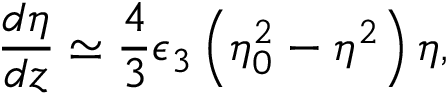Convert formula to latex. <formula><loc_0><loc_0><loc_500><loc_500>\frac { d \eta } { d z } \simeq \frac { 4 } { 3 } \epsilon _ { 3 } \left ( \eta _ { 0 } ^ { 2 } - \eta ^ { 2 } \right ) \eta ,</formula> 